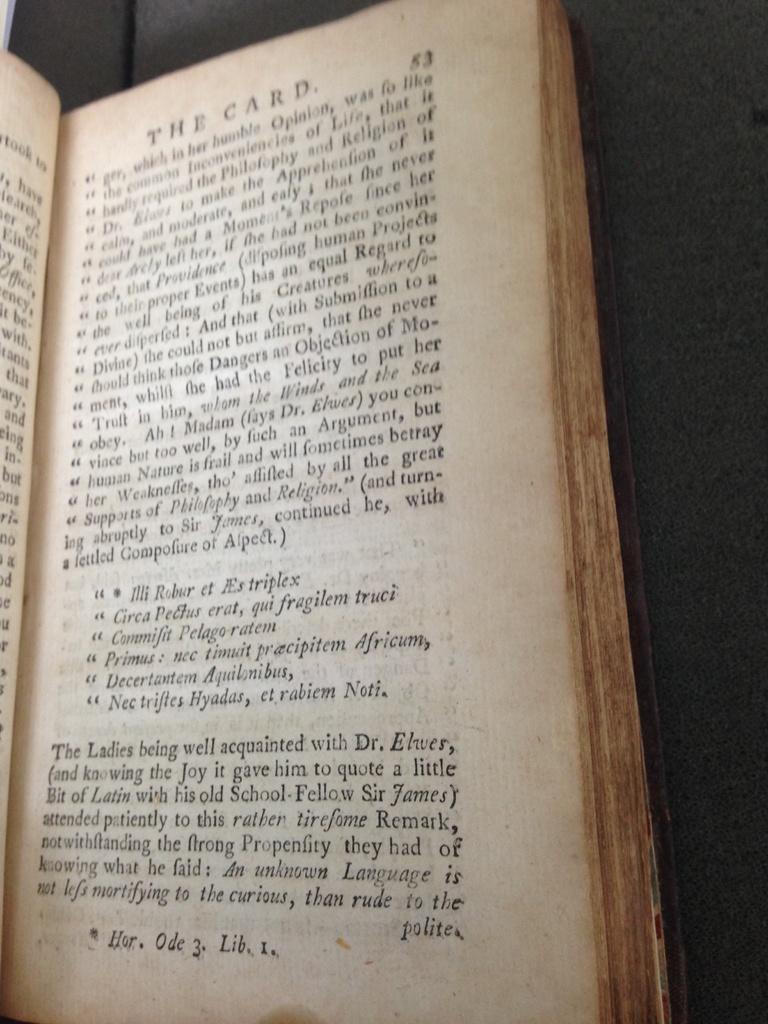What is the title of this book at the top of the page?
Provide a short and direct response. The card. What is the last word on the page?
Keep it short and to the point. Polite. 